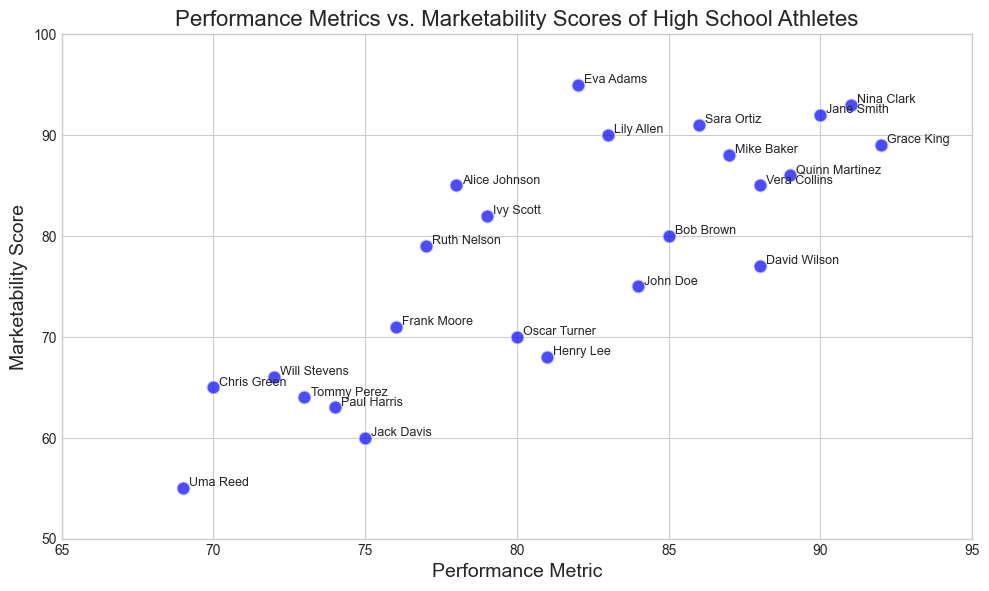How many athletes have a marketability score greater than 90? To find the answer, look for all data points above the horizontal line at Marketability Score 90. Identify the athlete names and count them. The athletes with scores greater than 90 are Jane Smith, Eva Adams, Nina Clark, and Sara Ortiz, so the count is 4.
Answer: 4 Which athlete has the highest marketability score, and what is their performance metric? Compare all the data points to identify the highest marketability score. The highest score is 95, achieved by Eva Adams. Her performance metric is 82.
Answer: Eva Adams, 82 Who has a lower performance metric, Frank Moore or Ruth Nelson, and by how much? Compare the performance metrics of Frank Moore (76) and Ruth Nelson (77). The difference between them is 1.
Answer: Frank Moore, by 1 What is the average marketability score of athletes with a performance metric above 85? Identify the athletes with performance metrics above 85: Jane Smith, David Wilson, Grace King, Mike Baker, Nina Clark, Sara Ortiz, Quinn Martinez, and Vera Collins. Their marketability scores are 92, 77, 89, 88, 93, 91, 86, and 85. Sum these scores (701) and divide by the number of athletes (8). The average is 701/8 = 87.625.
Answer: 87.625 Who has a better marketability score, Jack Davis or Uma Reed, and by how much? Compare the marketability scores of Jack Davis (60) and Uma Reed (55). The difference between them is 5.
Answer: Jack Davis, by 5 Which athlete has the highest performance metric, and what is their marketability score? Compare all the data points to identify the highest performance metric. The highest metric is 92, achieved by Grace King. Her marketability score is 89.
Answer: Grace King, 89 Are there more athletes with performance metrics below 80 or those with marketability scores below 70? Count the athletes with performance metrics below 80: Chris Green, Alice Johnson, Frank Moore, Oscar Turner, Jack Davis, Ruth Nelson, Paul Harris, Tommy Perez, and Uma Reed. There are 9 athletes. Then count the athletes with marketability scores below 70: John Doe, Chris Green, Henry Lee, Frank Moore, Jack Davis, Oscar Turner, Paul Harris, Tommy Perez, and Uma Reed. There are 9 athletes. The numbers are equal.
Answer: Equal What is the difference in marketability scores between Jane Smith and Lily Allen? Compare the marketability scores of Jane Smith (92) and Lily Allen (90). The difference between them is 2.
Answer: 2 Do more athletes have a performance metric between 80 and 90 or a marketability score between 70 and 80? Count the athletes with performance metrics between 80 and 90: John Doe, Bob Brown, David Wilson, Eva Adams, Henry Lee, Lily Allen, Mike Baker, Vera Collins. There are 8 athletes. Then count the athletes with marketability scores between 70 and 80: Frank Moore, Oscar Turner, John Doe, David Wilson, Bob Brown, Ruth Nelson, Henry Lee. There are 7 athletes. Hence, there are more athletes with performance metrics between 80 and 90.
Answer: Performance metric between 80 and 90 